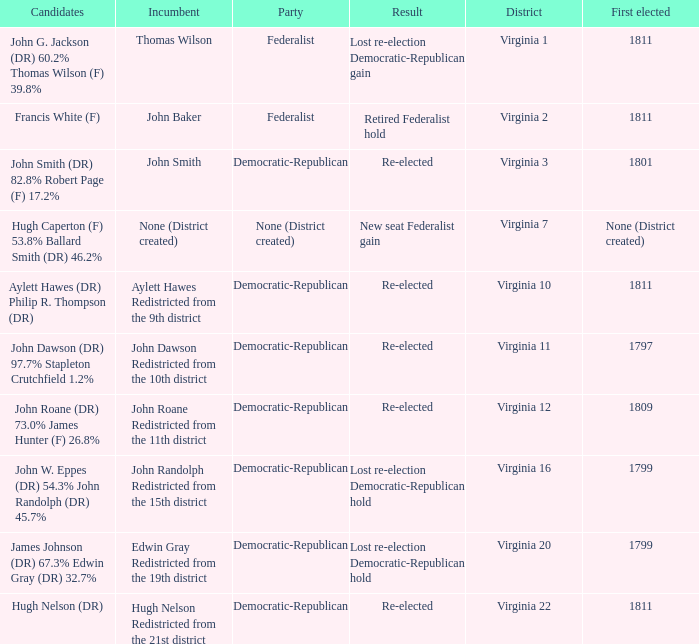Name the party for virginia 12 Democratic-Republican. 